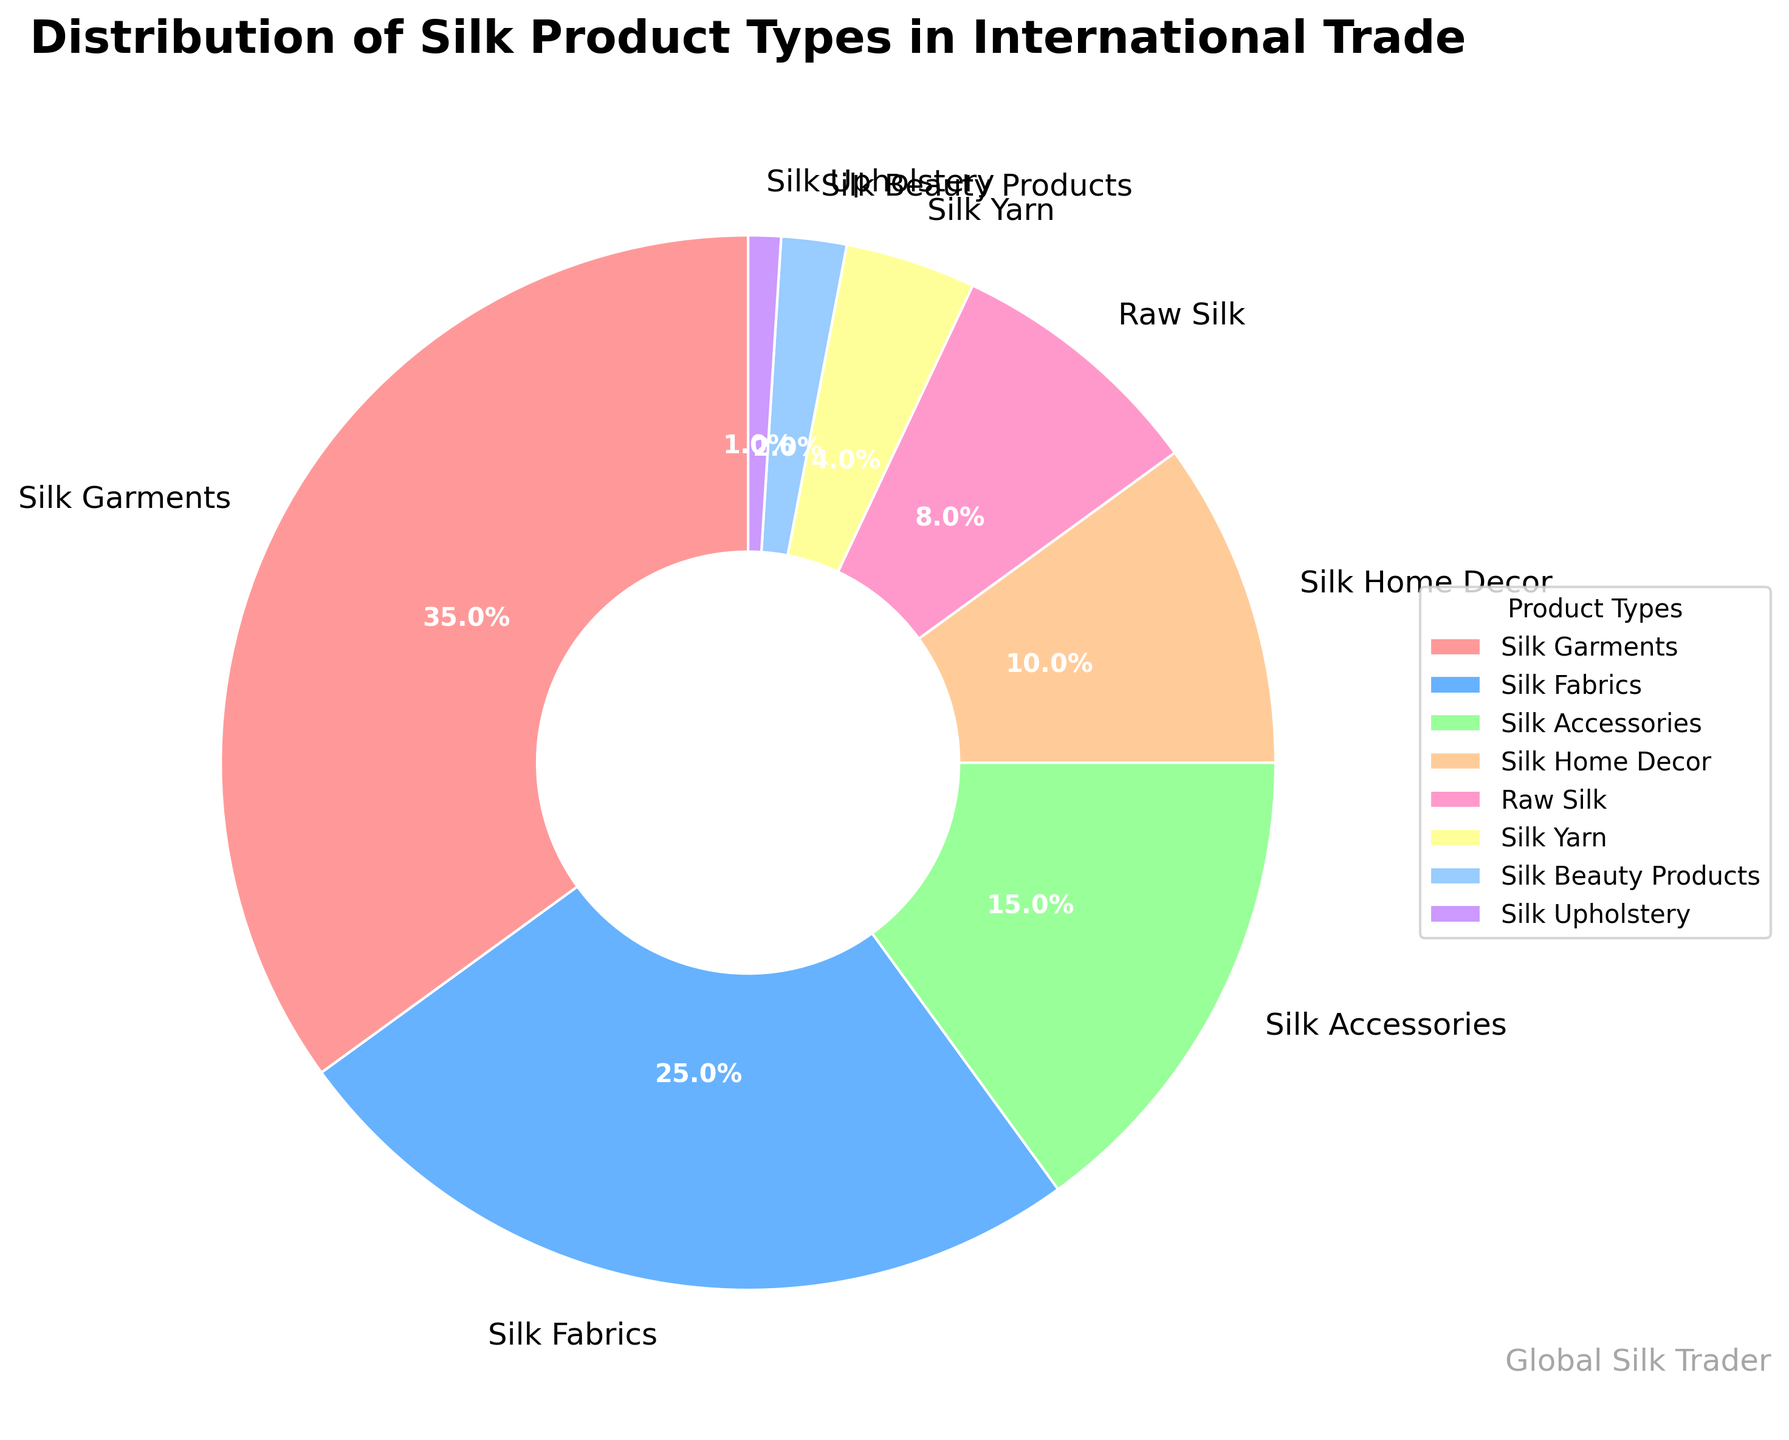What's the total percentage of Silk Garments and Silk Fabrics combined? Add the percentages of Silk Garments (35%) and Silk Fabrics (25%): 35 + 25 = 60
Answer: 60 Which product type has the smallest percentage in the distribution? By looking at the chart, Silk Upholstery has the smallest percentage.
Answer: Silk Upholstery How does the percentage of Silk Home Decor compare to that of Silk Accessories? Silk Home Decor accounts for 10%, while Silk Accessories account for 15%. Thus, Silk Accessories (15%) > Silk Home Decor (10%).
Answer: Silk Accessories > Silk Home Decor What is the difference in percentage between Raw Silk and Silk Beauty Products? Subtract the percentage of Silk Beauty Products (2%) from Raw Silk (8%): 8 - 2 = 6
Answer: 6 Among the listed silk product types, which one constitutes more than one-third of the total distribution? One-third of 100% is approximately 33.33%. Silk Garments constitute 35%, which is greater than 33.33%.
Answer: Silk Garments If we combine the percentages of Silk Yarn, Silk Beauty Products, and Silk Upholstery, what is the result? Add the percentages of Silk Yarn (4%), Silk Beauty Products (2%), and Silk Upholstery (1%): 4 + 2 + 1 = 7
Answer: 7 What is the percentage difference between Silk Fabrics and Silk Home Decor? Subtract the percentage of Silk Home Decor (10%) from Silk Fabrics (25%): 25 - 10 = 15
Answer: 15 Which product types occupy more than 20% of the distribution each? From the chart, Silk Garments (35%) and Silk Fabrics (25%) each occupy more than 20%.
Answer: Silk Garments and Silk Fabrics What is the combined percentage of all products except Silk Garments? Subtract the percentage of Silk Garments (35%) from the total 100%: 100 - 35 = 65
Answer: 65 